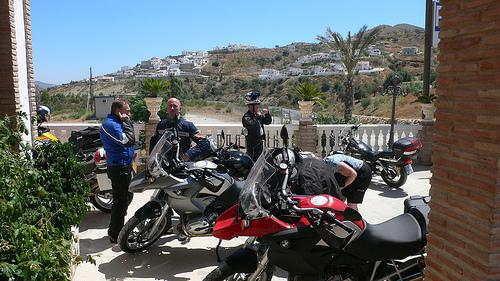How many motorbikes would there be in the image if two motorbikes were deleted from the scene? If two motorbikes were removed from the scene depicted in the picture, where three motorbikes are originally visible, there would be one motorbike remaining. 